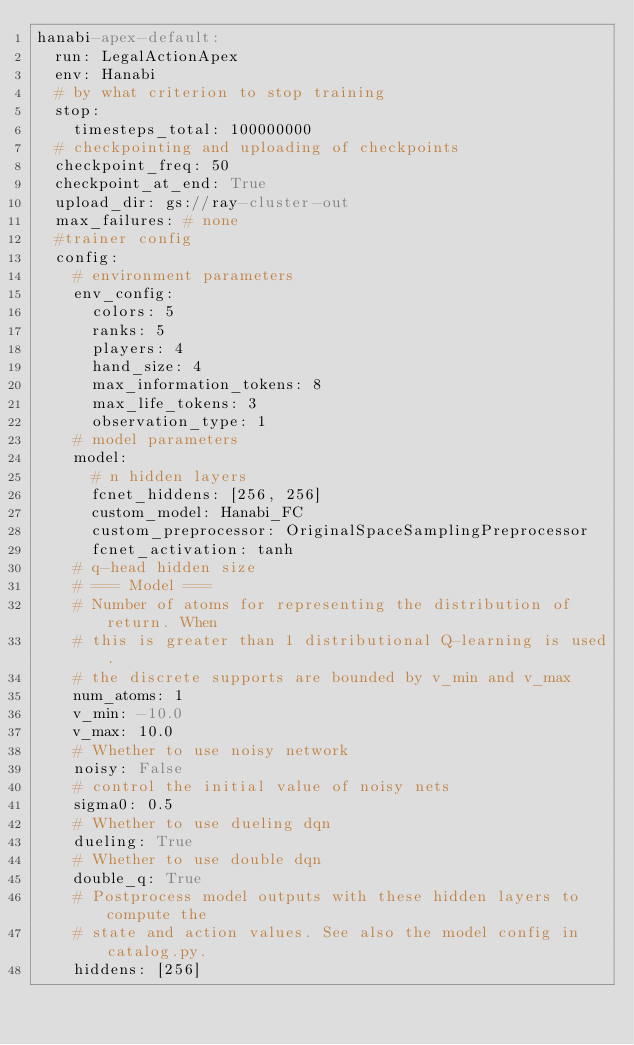Convert code to text. <code><loc_0><loc_0><loc_500><loc_500><_YAML_>hanabi-apex-default:
  run: LegalActionApex
  env: Hanabi
  # by what criterion to stop training
  stop:
    timesteps_total: 100000000
  # checkpointing and uploading of checkpoints
  checkpoint_freq: 50
  checkpoint_at_end: True
  upload_dir: gs://ray-cluster-out
  max_failures: # none
  #trainer config
  config:
    # environment parameters
    env_config:
      colors: 5
      ranks: 5
      players: 4
      hand_size: 4
      max_information_tokens: 8
      max_life_tokens: 3
      observation_type: 1
    # model parameters
    model:
      # n hidden layers
      fcnet_hiddens: [256, 256]
      custom_model: Hanabi_FC
      custom_preprocessor: OriginalSpaceSamplingPreprocessor
      fcnet_activation: tanh
    # q-head hidden size
    # === Model ===
    # Number of atoms for representing the distribution of return. When
    # this is greater than 1 distributional Q-learning is used.
    # the discrete supports are bounded by v_min and v_max
    num_atoms: 1
    v_min: -10.0
    v_max: 10.0
    # Whether to use noisy network
    noisy: False
    # control the initial value of noisy nets
    sigma0: 0.5
    # Whether to use dueling dqn
    dueling: True
    # Whether to use double dqn
    double_q: True
    # Postprocess model outputs with these hidden layers to compute the
    # state and action values. See also the model config in catalog.py.
    hiddens: [256]</code> 